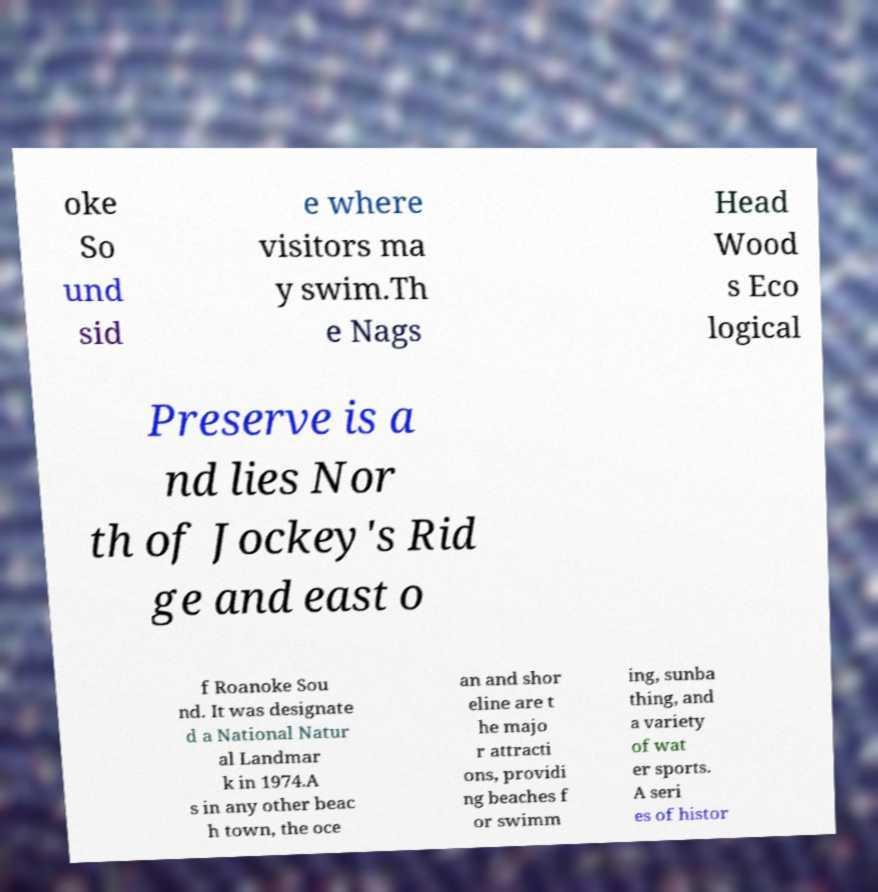Please identify and transcribe the text found in this image. oke So und sid e where visitors ma y swim.Th e Nags Head Wood s Eco logical Preserve is a nd lies Nor th of Jockey's Rid ge and east o f Roanoke Sou nd. It was designate d a National Natur al Landmar k in 1974.A s in any other beac h town, the oce an and shor eline are t he majo r attracti ons, providi ng beaches f or swimm ing, sunba thing, and a variety of wat er sports. A seri es of histor 